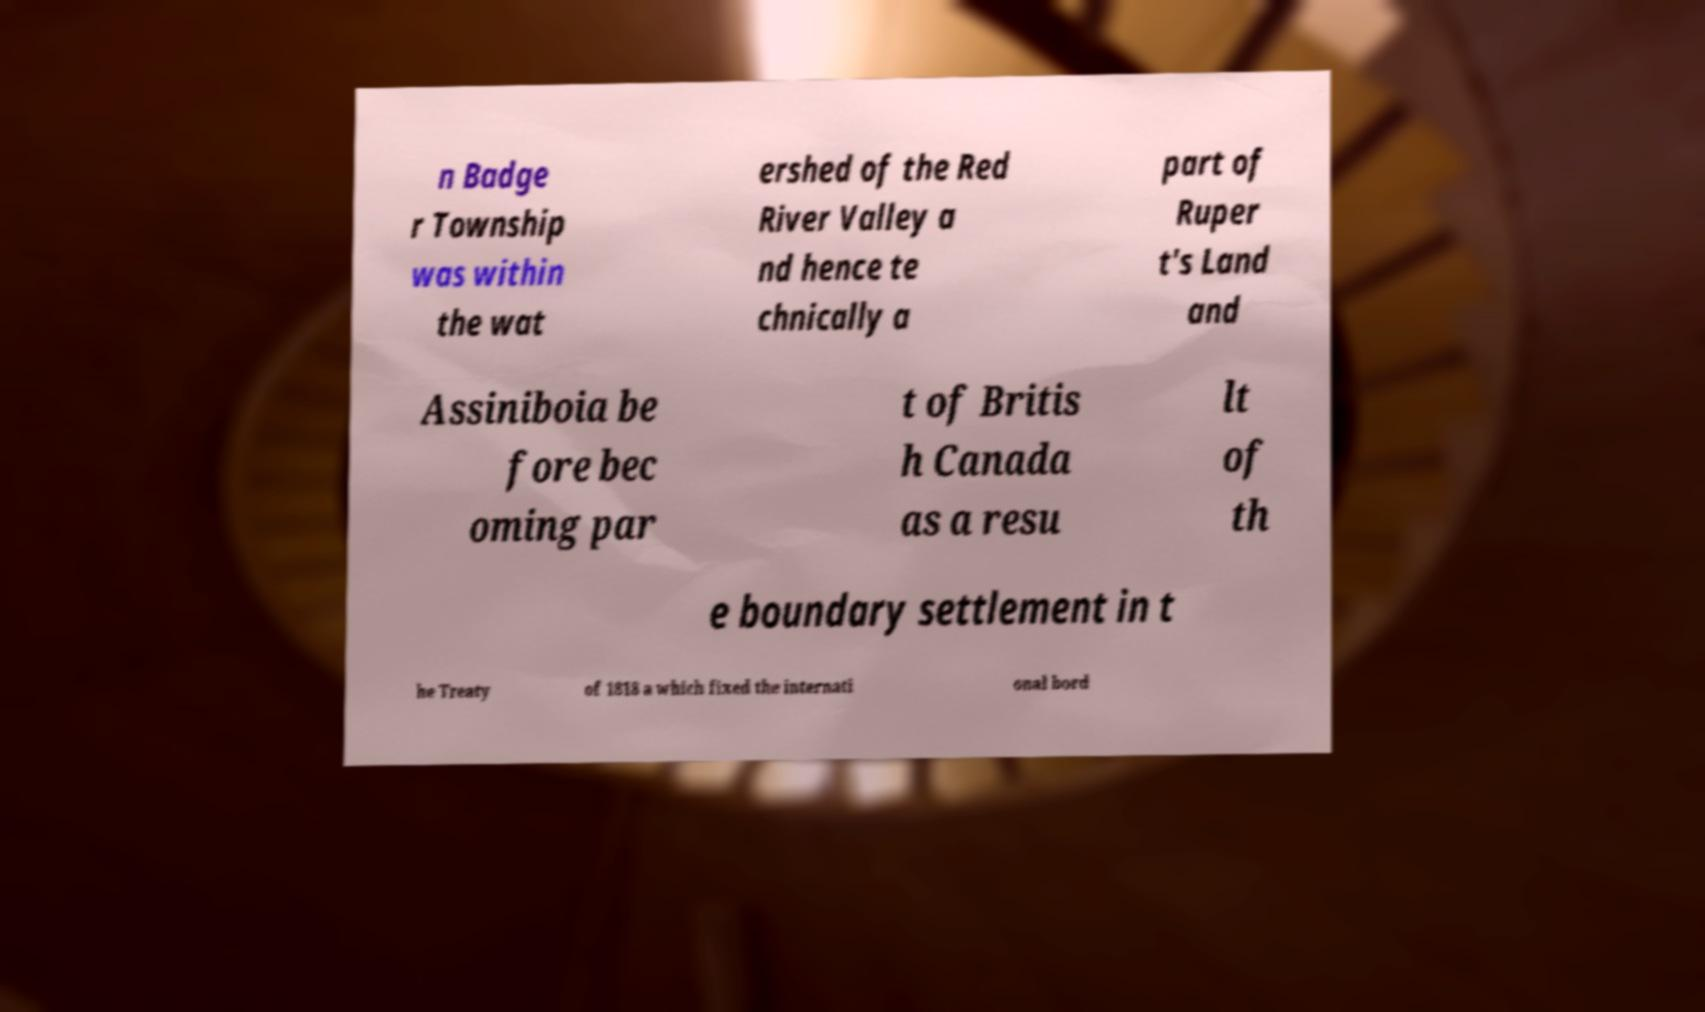I need the written content from this picture converted into text. Can you do that? n Badge r Township was within the wat ershed of the Red River Valley a nd hence te chnically a part of Ruper t's Land and Assiniboia be fore bec oming par t of Britis h Canada as a resu lt of th e boundary settlement in t he Treaty of 1818 a which fixed the internati onal bord 